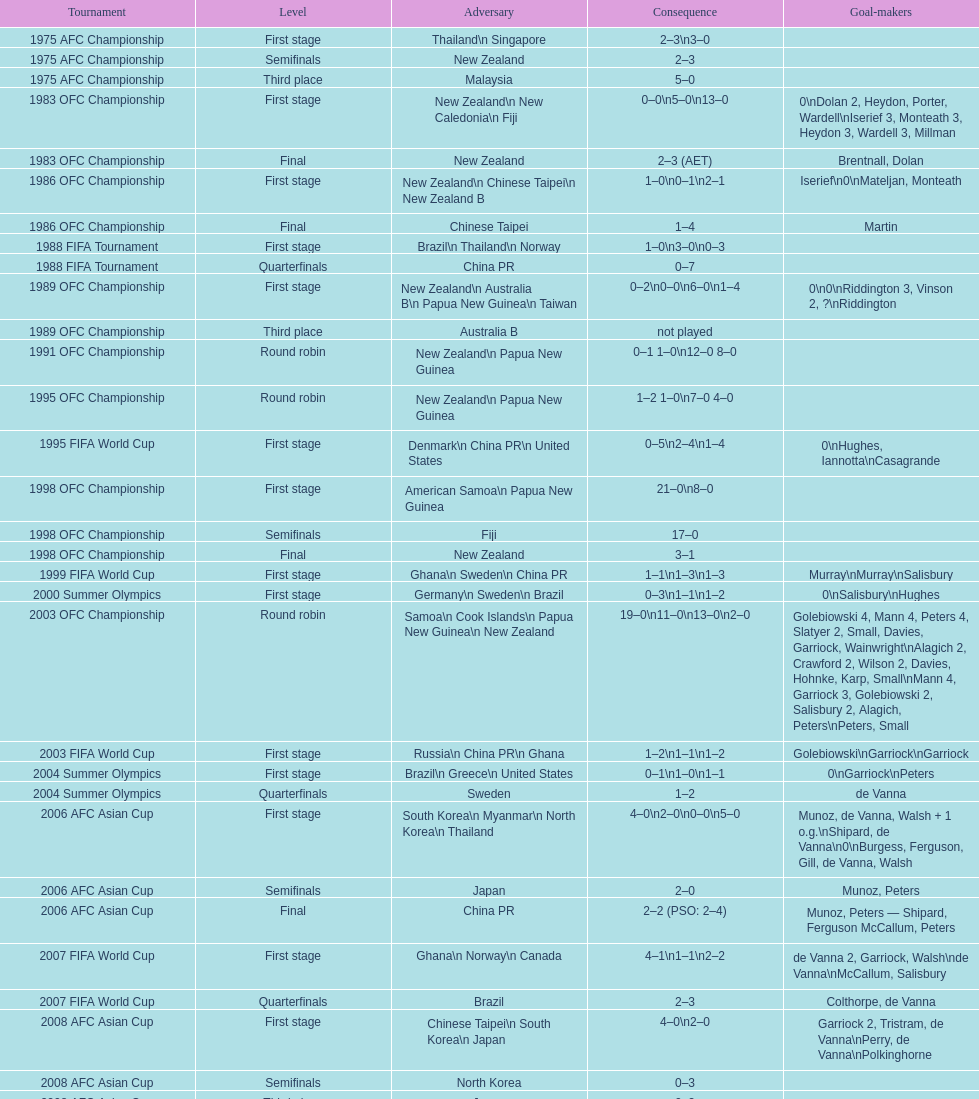How many stages were round robins? 3. 